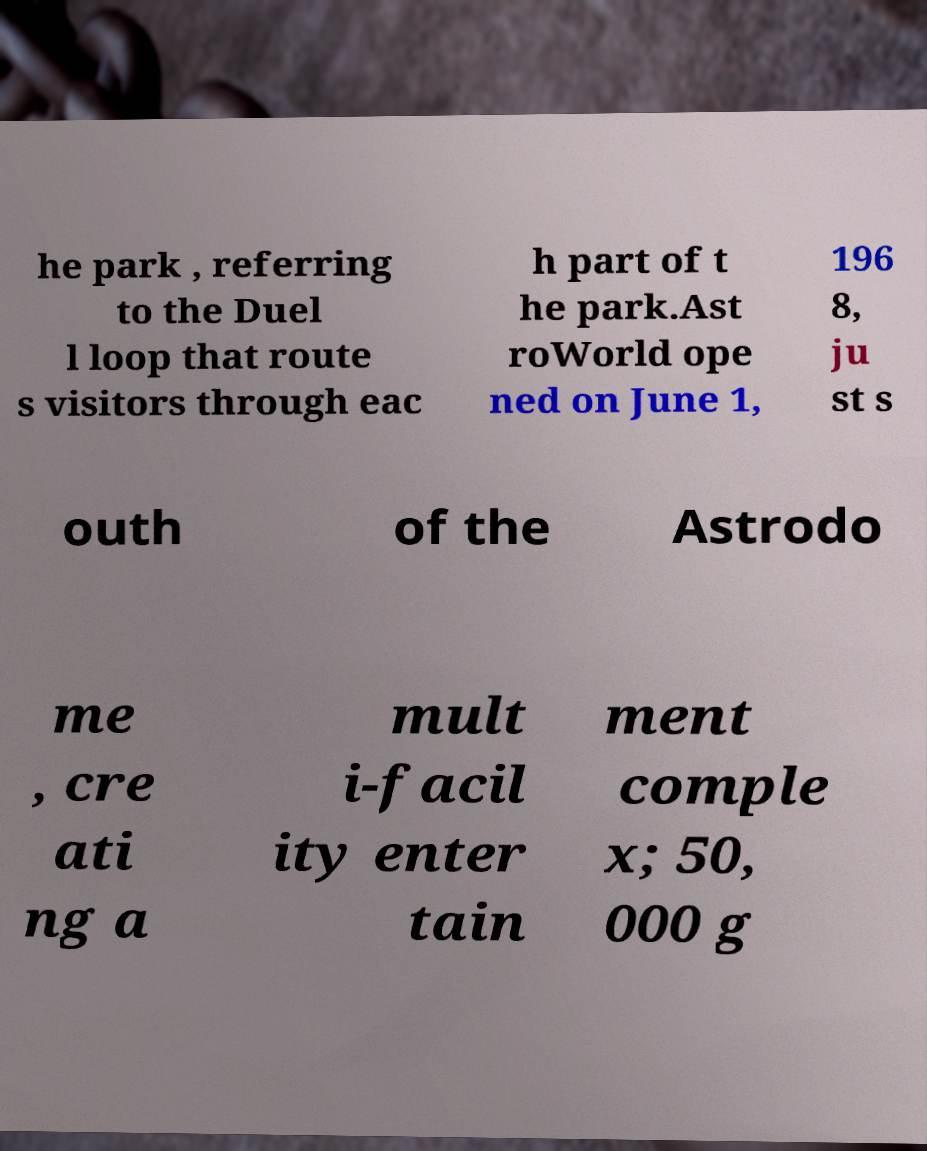Can you read and provide the text displayed in the image?This photo seems to have some interesting text. Can you extract and type it out for me? he park , referring to the Duel l loop that route s visitors through eac h part of t he park.Ast roWorld ope ned on June 1, 196 8, ju st s outh of the Astrodo me , cre ati ng a mult i-facil ity enter tain ment comple x; 50, 000 g 